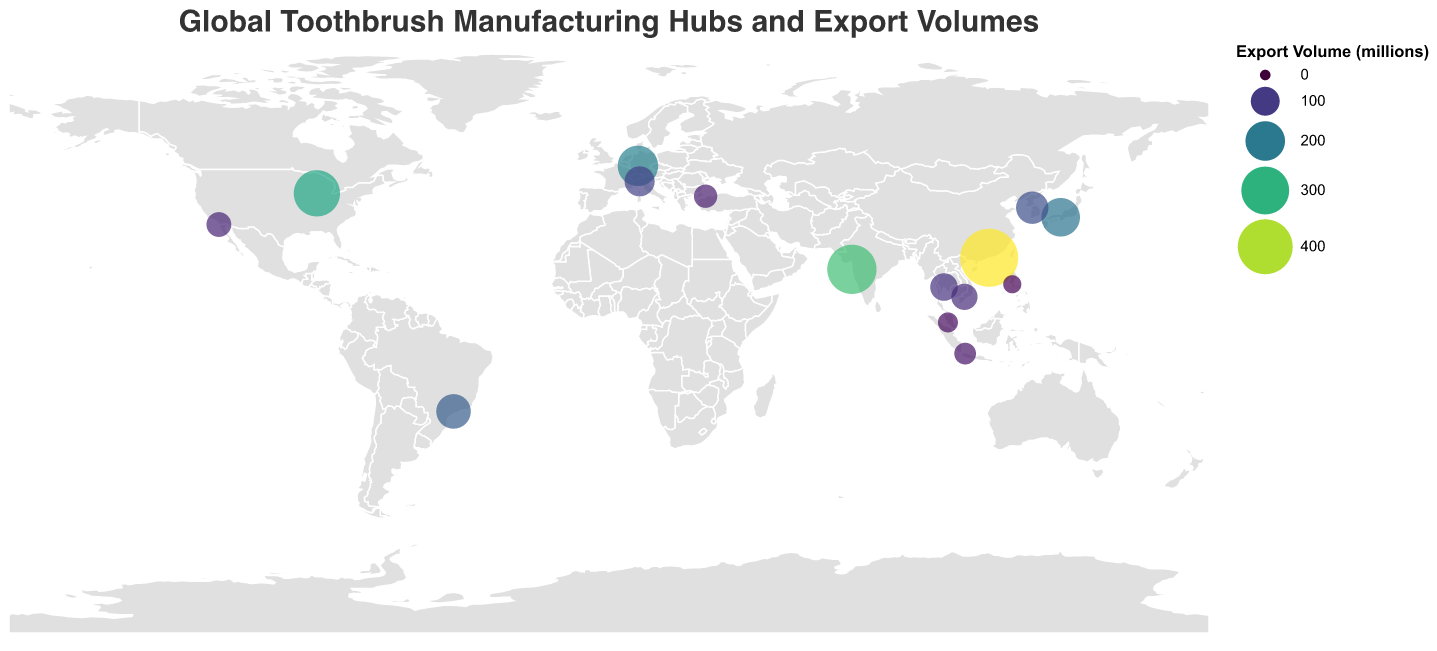What's the title of the figure? The title of the figure is displayed at the top and is usually the largest text on the plot. It provides a concise summary of what the figure is about.
Answer: Global Toothbrush Manufacturing Hubs and Export Volumes Which country has the largest export volume of toothbrushes? The size and color intensity of the circle represent the export volume. The largest circle with the most intense color is located in China (Shenzhen).
Answer: China How many countries are represented in the figure? Each circle represents a country. By counting the number of circles, we find the total number of countries.
Answer: 15 What is the total export volume of toothbrushes from Japan and South Korea combined? Find the export volumes for Japan (190 million) and South Korea (130 million) and sum them up: 190 + 130 = 320 million.
Answer: 320 million Which manufacturing hub in the figure has the smallest export volume? The smallest circle with the lightest color indicates the smallest export volume. This is located in the Philippines (Manila).
Answer: Manila Compare the export volumes of Mumbai and Chicago and determine which one exports more toothbrushes. Locate the circles for Mumbai and Chicago. Mumbai has an export volume of 320 million, while Chicago has 280 million. Therefore, Mumbai exports more toothbrushes.
Answer: Mumbai Is the export volume of toothbrushes from Brazil greater than that of Italy? Compare the circles for Brazil (Sao Paulo) and Italy (Milan). Sao Paulo's export volume is 150 million, while Milan's is 110 million. Hence, Sao Paulo exports more.
Answer: Yes What is the average export volume of toothbrushes for all hubs? Sum all the export volumes: (450 + 320 + 280 + 210 + 190 + 150 + 130 + 110 + 90 + 80 + 70 + 60 + 50 + 40 + 30) = 2260. Divide by the number of hubs (15): 2260 / 15 = 150.67 million.
Answer: 150.67 million Which continent has the most manufacturing hubs represented in the figure? Count the number of manufacturing hubs on each continent. Asia has the most hubs, including China, India, Japan, South Korea, Thailand, Vietnam, Indonesia, Malaysia, and the Philippines.
Answer: Asia 